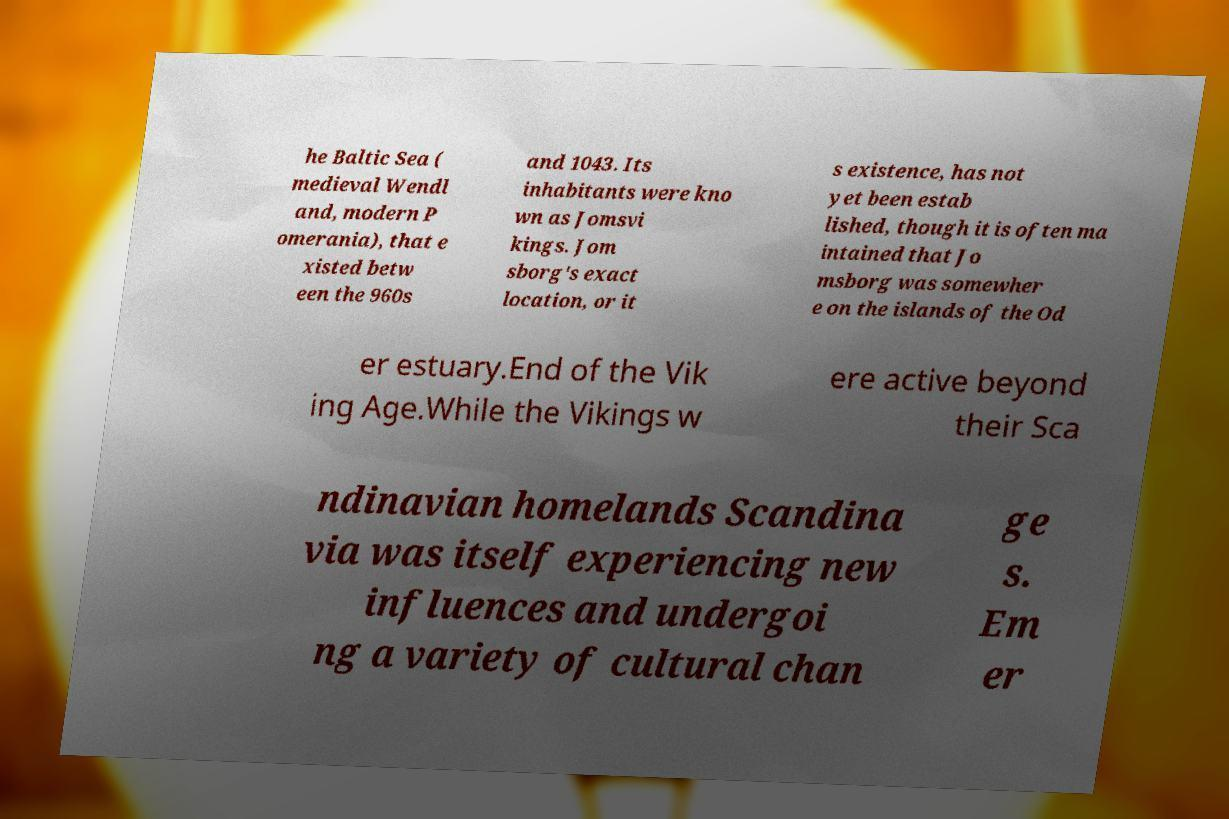I need the written content from this picture converted into text. Can you do that? he Baltic Sea ( medieval Wendl and, modern P omerania), that e xisted betw een the 960s and 1043. Its inhabitants were kno wn as Jomsvi kings. Jom sborg's exact location, or it s existence, has not yet been estab lished, though it is often ma intained that Jo msborg was somewher e on the islands of the Od er estuary.End of the Vik ing Age.While the Vikings w ere active beyond their Sca ndinavian homelands Scandina via was itself experiencing new influences and undergoi ng a variety of cultural chan ge s. Em er 